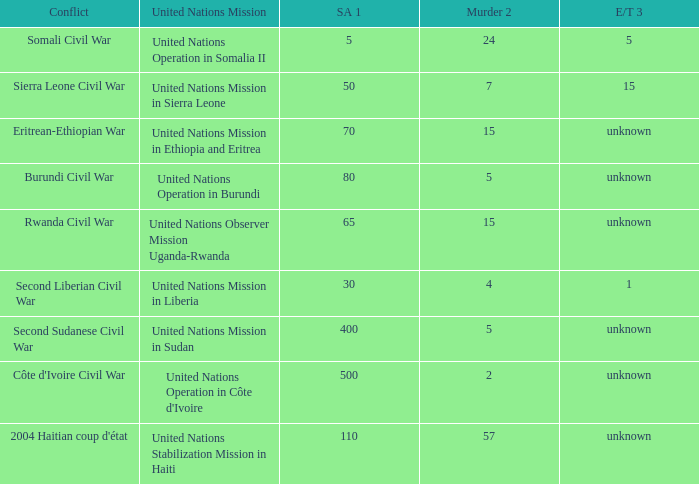What is the sexual abuse rate where the conflict is the Second Sudanese Civil War? 400.0. 